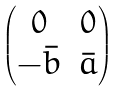Convert formula to latex. <formula><loc_0><loc_0><loc_500><loc_500>\begin{pmatrix} 0 & 0 \\ - \bar { b } & \bar { a } \end{pmatrix}</formula> 